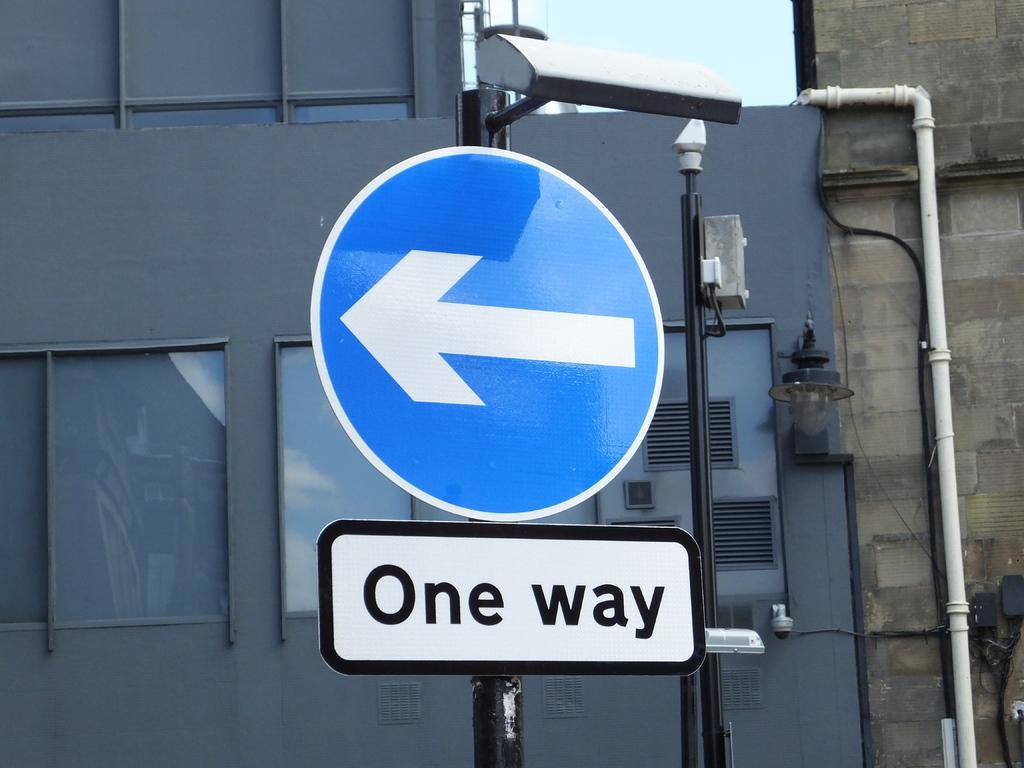In which direction is the sign directing traffic?
Ensure brevity in your answer.  One way. Does this one way have any way to turn around?
Your answer should be compact. Unanswerable. 